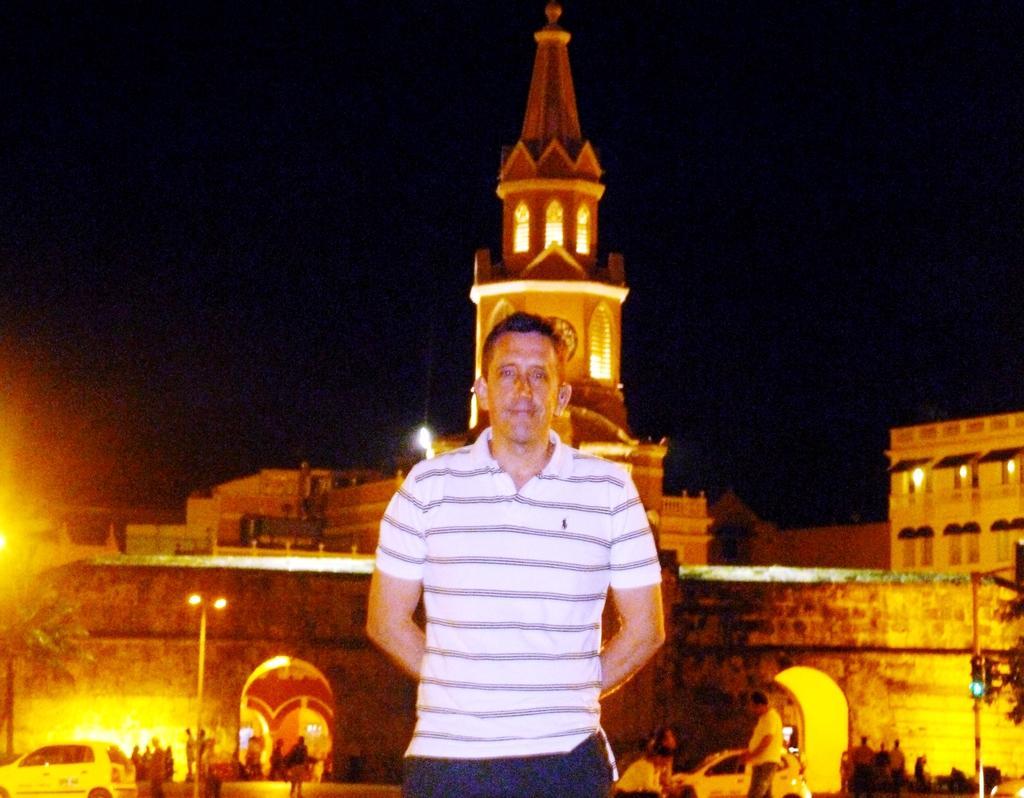How would you summarize this image in a sentence or two? This is the picture of a building. In this image there is a person standing in the foreground. At the back there is a building. There are trees, vehicles and poles. At the top there is sky. 